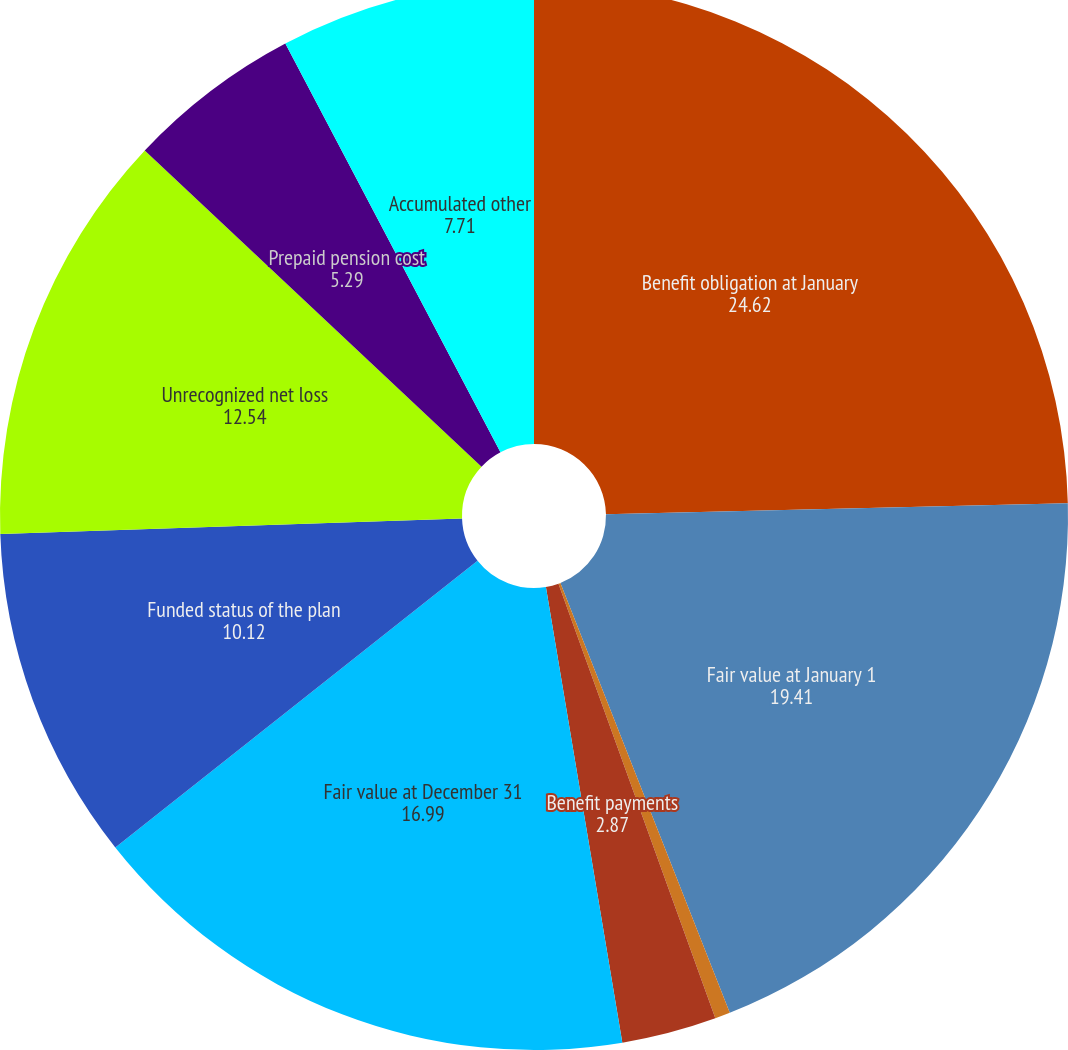Convert chart to OTSL. <chart><loc_0><loc_0><loc_500><loc_500><pie_chart><fcel>Benefit obligation at January<fcel>Fair value at January 1<fcel>Return on plan assets<fcel>Benefit payments<fcel>Fair value at December 31<fcel>Funded status of the plan<fcel>Unrecognized net loss<fcel>Prepaid pension cost<fcel>Accumulated other<nl><fcel>24.62%<fcel>19.41%<fcel>0.46%<fcel>2.87%<fcel>16.99%<fcel>10.12%<fcel>12.54%<fcel>5.29%<fcel>7.71%<nl></chart> 